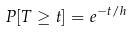<formula> <loc_0><loc_0><loc_500><loc_500>P [ T \geq t ] = e ^ { - t / h }</formula> 